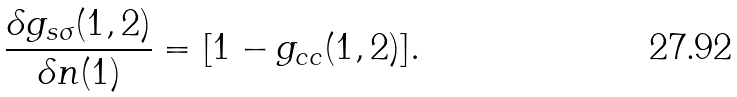Convert formula to latex. <formula><loc_0><loc_0><loc_500><loc_500>\frac { \delta g _ { s \sigma } ( 1 , 2 ) } { \delta n ( 1 ) } = [ 1 - g _ { c c } ( 1 , 2 ) ] .</formula> 